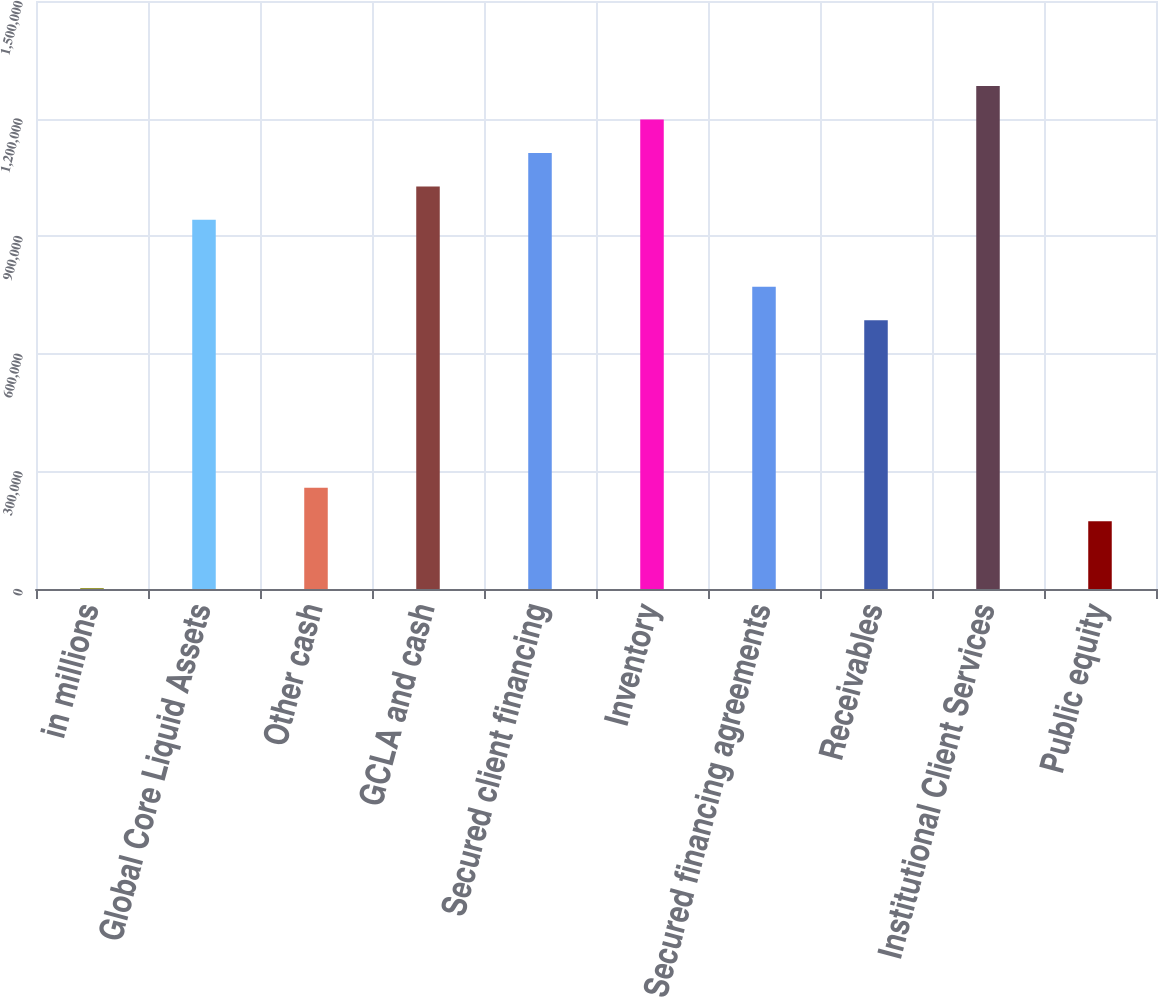Convert chart to OTSL. <chart><loc_0><loc_0><loc_500><loc_500><bar_chart><fcel>in millions<fcel>Global Core Liquid Assets<fcel>Other cash<fcel>GCLA and cash<fcel>Secured client financing<fcel>Inventory<fcel>Secured financing agreements<fcel>Receivables<fcel>Institutional Client Services<fcel>Public equity<nl><fcel>2014<fcel>941663<fcel>258282<fcel>1.02709e+06<fcel>1.11251e+06<fcel>1.19793e+06<fcel>770817<fcel>685395<fcel>1.28335e+06<fcel>172859<nl></chart> 